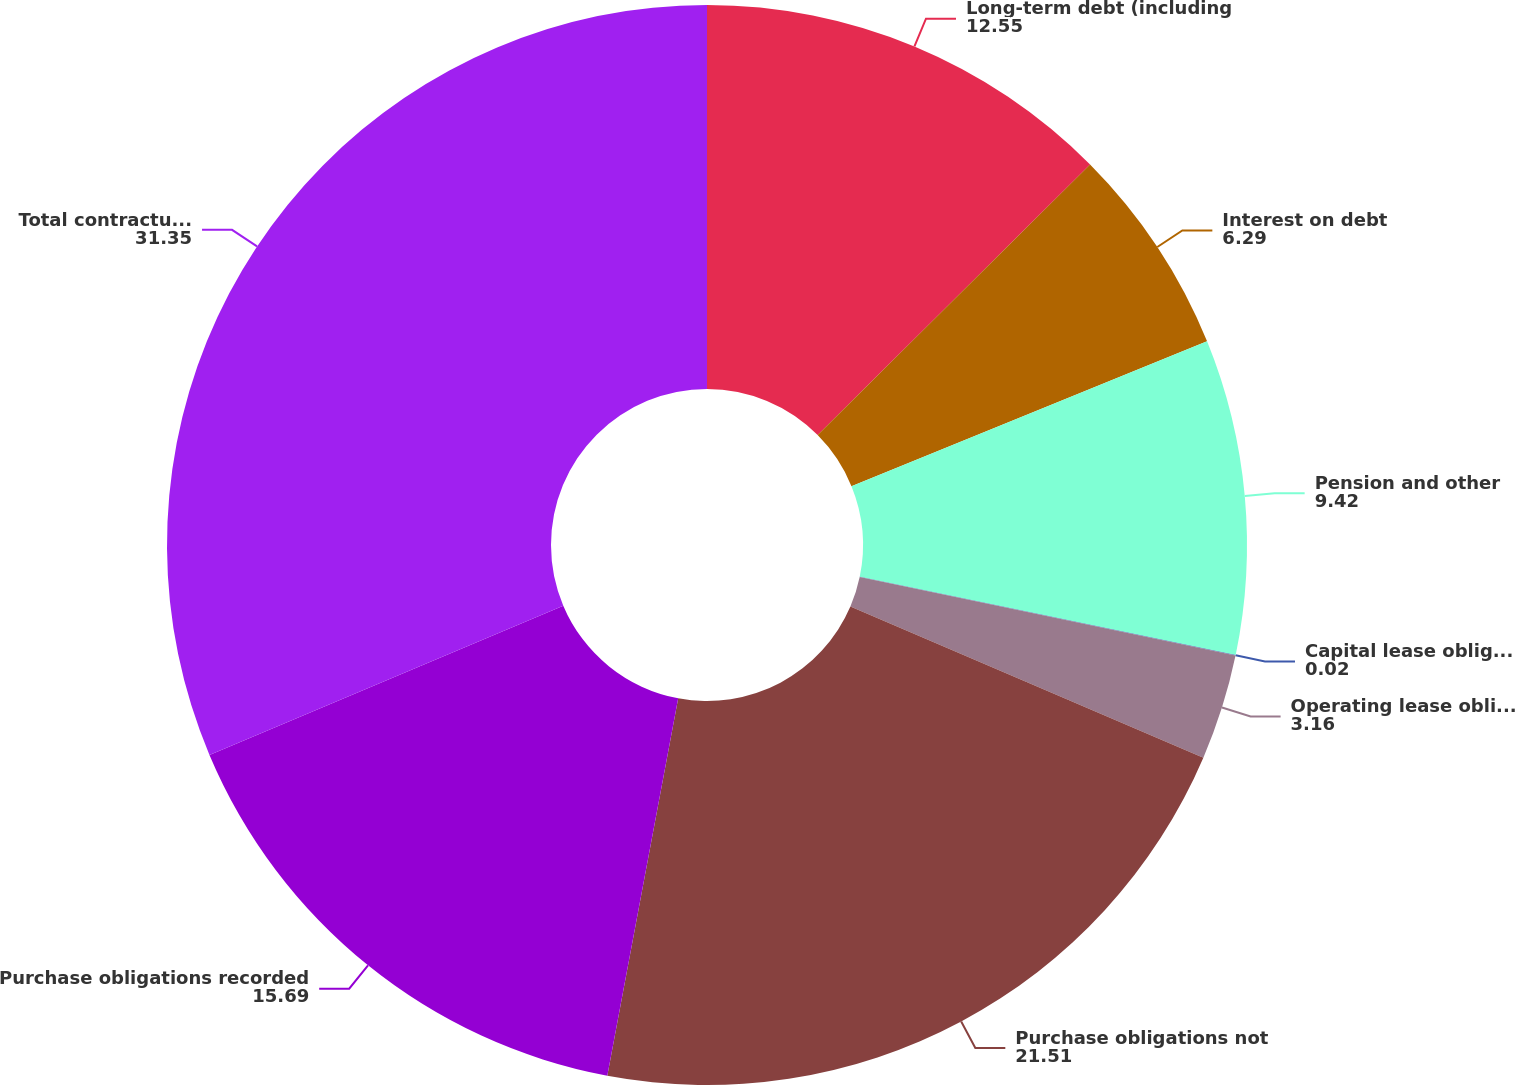Convert chart to OTSL. <chart><loc_0><loc_0><loc_500><loc_500><pie_chart><fcel>Long-term debt (including<fcel>Interest on debt<fcel>Pension and other<fcel>Capital lease obligations<fcel>Operating lease obligations<fcel>Purchase obligations not<fcel>Purchase obligations recorded<fcel>Total contractual obligations<nl><fcel>12.55%<fcel>6.29%<fcel>9.42%<fcel>0.02%<fcel>3.16%<fcel>21.51%<fcel>15.69%<fcel>31.35%<nl></chart> 